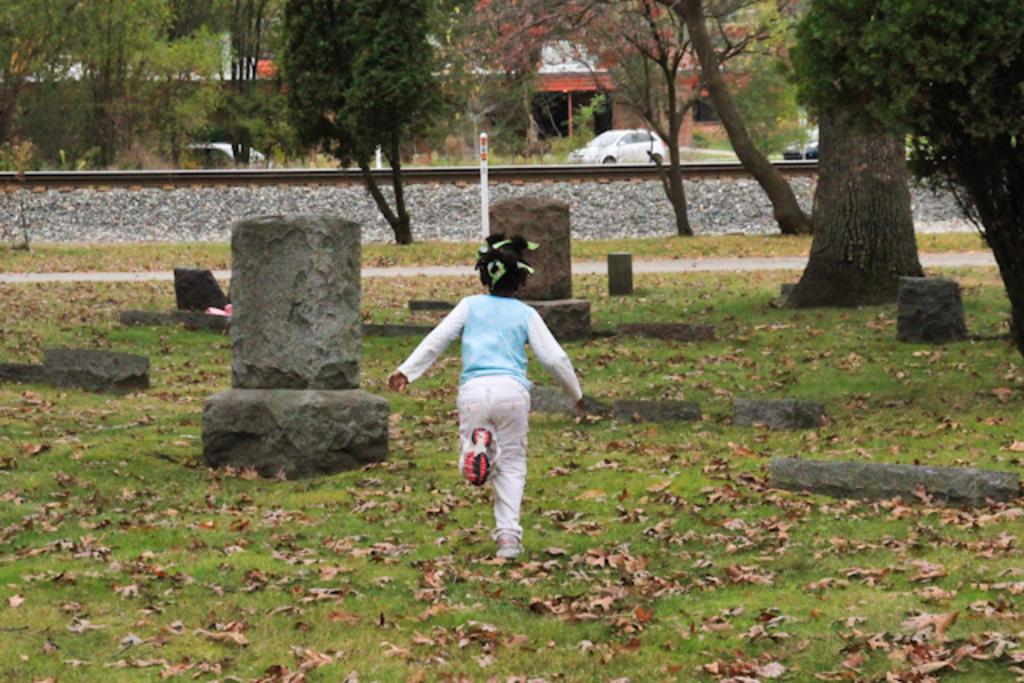What is the kid doing in the image? The kid is standing on the grass in the image. What can be seen in the background of the image? In the background, there are rocks, vehicles, a railway track, a building, and trees. How many different elements can be seen in the background of the image? There are five different elements visible in the background: rocks, vehicles, a railway track, a building, and trees. What type of cherries are hanging from the trees in the image? There are no cherries present in the image; only trees are visible in the background. How is the spoon used in the image? There is no spoon present in the image. 